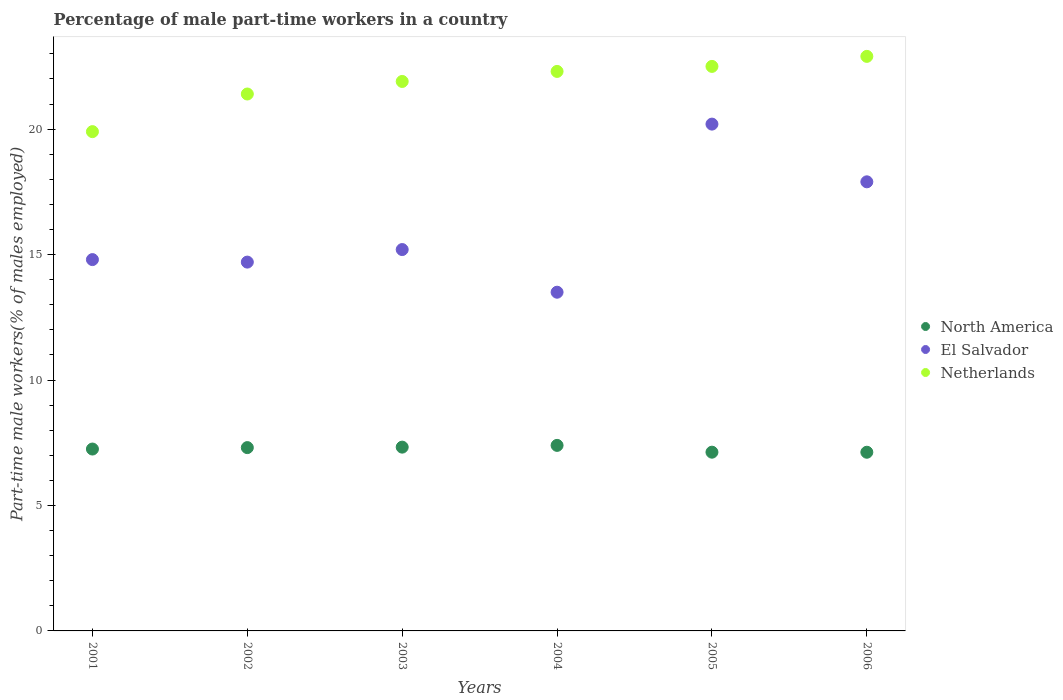How many different coloured dotlines are there?
Keep it short and to the point. 3. What is the percentage of male part-time workers in North America in 2006?
Make the answer very short. 7.12. Across all years, what is the maximum percentage of male part-time workers in El Salvador?
Make the answer very short. 20.2. Across all years, what is the minimum percentage of male part-time workers in El Salvador?
Provide a short and direct response. 13.5. In which year was the percentage of male part-time workers in North America minimum?
Keep it short and to the point. 2006. What is the total percentage of male part-time workers in Netherlands in the graph?
Ensure brevity in your answer.  130.9. What is the difference between the percentage of male part-time workers in Netherlands in 2003 and that in 2006?
Make the answer very short. -1. What is the difference between the percentage of male part-time workers in Netherlands in 2004 and the percentage of male part-time workers in El Salvador in 2002?
Offer a terse response. 7.6. What is the average percentage of male part-time workers in El Salvador per year?
Ensure brevity in your answer.  16.05. In the year 2004, what is the difference between the percentage of male part-time workers in Netherlands and percentage of male part-time workers in North America?
Your response must be concise. 14.91. What is the ratio of the percentage of male part-time workers in El Salvador in 2002 to that in 2005?
Keep it short and to the point. 0.73. Is the difference between the percentage of male part-time workers in Netherlands in 2002 and 2006 greater than the difference between the percentage of male part-time workers in North America in 2002 and 2006?
Keep it short and to the point. No. What is the difference between the highest and the second highest percentage of male part-time workers in El Salvador?
Keep it short and to the point. 2.3. What is the difference between the highest and the lowest percentage of male part-time workers in North America?
Keep it short and to the point. 0.27. Is the sum of the percentage of male part-time workers in El Salvador in 2001 and 2006 greater than the maximum percentage of male part-time workers in Netherlands across all years?
Make the answer very short. Yes. Is the percentage of male part-time workers in El Salvador strictly greater than the percentage of male part-time workers in North America over the years?
Provide a short and direct response. Yes. Is the percentage of male part-time workers in El Salvador strictly less than the percentage of male part-time workers in Netherlands over the years?
Offer a very short reply. Yes. How many dotlines are there?
Keep it short and to the point. 3. How many years are there in the graph?
Keep it short and to the point. 6. Are the values on the major ticks of Y-axis written in scientific E-notation?
Offer a very short reply. No. Does the graph contain grids?
Your answer should be very brief. No. How are the legend labels stacked?
Provide a succinct answer. Vertical. What is the title of the graph?
Make the answer very short. Percentage of male part-time workers in a country. What is the label or title of the X-axis?
Provide a succinct answer. Years. What is the label or title of the Y-axis?
Offer a terse response. Part-time male workers(% of males employed). What is the Part-time male workers(% of males employed) of North America in 2001?
Make the answer very short. 7.25. What is the Part-time male workers(% of males employed) of El Salvador in 2001?
Offer a very short reply. 14.8. What is the Part-time male workers(% of males employed) in Netherlands in 2001?
Offer a terse response. 19.9. What is the Part-time male workers(% of males employed) in North America in 2002?
Offer a very short reply. 7.31. What is the Part-time male workers(% of males employed) of El Salvador in 2002?
Keep it short and to the point. 14.7. What is the Part-time male workers(% of males employed) in Netherlands in 2002?
Provide a succinct answer. 21.4. What is the Part-time male workers(% of males employed) of North America in 2003?
Provide a succinct answer. 7.33. What is the Part-time male workers(% of males employed) of El Salvador in 2003?
Give a very brief answer. 15.2. What is the Part-time male workers(% of males employed) in Netherlands in 2003?
Offer a terse response. 21.9. What is the Part-time male workers(% of males employed) in North America in 2004?
Keep it short and to the point. 7.39. What is the Part-time male workers(% of males employed) in Netherlands in 2004?
Your answer should be very brief. 22.3. What is the Part-time male workers(% of males employed) in North America in 2005?
Provide a succinct answer. 7.12. What is the Part-time male workers(% of males employed) of El Salvador in 2005?
Offer a very short reply. 20.2. What is the Part-time male workers(% of males employed) in North America in 2006?
Provide a succinct answer. 7.12. What is the Part-time male workers(% of males employed) in El Salvador in 2006?
Ensure brevity in your answer.  17.9. What is the Part-time male workers(% of males employed) of Netherlands in 2006?
Your answer should be very brief. 22.9. Across all years, what is the maximum Part-time male workers(% of males employed) in North America?
Provide a succinct answer. 7.39. Across all years, what is the maximum Part-time male workers(% of males employed) of El Salvador?
Your answer should be very brief. 20.2. Across all years, what is the maximum Part-time male workers(% of males employed) of Netherlands?
Give a very brief answer. 22.9. Across all years, what is the minimum Part-time male workers(% of males employed) of North America?
Your response must be concise. 7.12. Across all years, what is the minimum Part-time male workers(% of males employed) of Netherlands?
Provide a short and direct response. 19.9. What is the total Part-time male workers(% of males employed) in North America in the graph?
Your answer should be very brief. 43.52. What is the total Part-time male workers(% of males employed) of El Salvador in the graph?
Your answer should be compact. 96.3. What is the total Part-time male workers(% of males employed) of Netherlands in the graph?
Provide a short and direct response. 130.9. What is the difference between the Part-time male workers(% of males employed) of North America in 2001 and that in 2002?
Offer a terse response. -0.06. What is the difference between the Part-time male workers(% of males employed) in North America in 2001 and that in 2003?
Ensure brevity in your answer.  -0.08. What is the difference between the Part-time male workers(% of males employed) in El Salvador in 2001 and that in 2003?
Make the answer very short. -0.4. What is the difference between the Part-time male workers(% of males employed) in North America in 2001 and that in 2004?
Keep it short and to the point. -0.15. What is the difference between the Part-time male workers(% of males employed) of El Salvador in 2001 and that in 2004?
Make the answer very short. 1.3. What is the difference between the Part-time male workers(% of males employed) in Netherlands in 2001 and that in 2004?
Your answer should be compact. -2.4. What is the difference between the Part-time male workers(% of males employed) of North America in 2001 and that in 2005?
Your response must be concise. 0.13. What is the difference between the Part-time male workers(% of males employed) of North America in 2001 and that in 2006?
Your response must be concise. 0.13. What is the difference between the Part-time male workers(% of males employed) of El Salvador in 2001 and that in 2006?
Your answer should be compact. -3.1. What is the difference between the Part-time male workers(% of males employed) of Netherlands in 2001 and that in 2006?
Your answer should be compact. -3. What is the difference between the Part-time male workers(% of males employed) of North America in 2002 and that in 2003?
Make the answer very short. -0.02. What is the difference between the Part-time male workers(% of males employed) of El Salvador in 2002 and that in 2003?
Make the answer very short. -0.5. What is the difference between the Part-time male workers(% of males employed) of North America in 2002 and that in 2004?
Give a very brief answer. -0.09. What is the difference between the Part-time male workers(% of males employed) of El Salvador in 2002 and that in 2004?
Your answer should be very brief. 1.2. What is the difference between the Part-time male workers(% of males employed) in Netherlands in 2002 and that in 2004?
Make the answer very short. -0.9. What is the difference between the Part-time male workers(% of males employed) in North America in 2002 and that in 2005?
Your response must be concise. 0.18. What is the difference between the Part-time male workers(% of males employed) in El Salvador in 2002 and that in 2005?
Provide a succinct answer. -5.5. What is the difference between the Part-time male workers(% of males employed) of Netherlands in 2002 and that in 2005?
Provide a short and direct response. -1.1. What is the difference between the Part-time male workers(% of males employed) in North America in 2002 and that in 2006?
Give a very brief answer. 0.18. What is the difference between the Part-time male workers(% of males employed) in El Salvador in 2002 and that in 2006?
Make the answer very short. -3.2. What is the difference between the Part-time male workers(% of males employed) in North America in 2003 and that in 2004?
Give a very brief answer. -0.07. What is the difference between the Part-time male workers(% of males employed) of Netherlands in 2003 and that in 2004?
Keep it short and to the point. -0.4. What is the difference between the Part-time male workers(% of males employed) in North America in 2003 and that in 2005?
Provide a succinct answer. 0.2. What is the difference between the Part-time male workers(% of males employed) of El Salvador in 2003 and that in 2005?
Your response must be concise. -5. What is the difference between the Part-time male workers(% of males employed) of North America in 2003 and that in 2006?
Provide a short and direct response. 0.2. What is the difference between the Part-time male workers(% of males employed) of Netherlands in 2003 and that in 2006?
Ensure brevity in your answer.  -1. What is the difference between the Part-time male workers(% of males employed) of North America in 2004 and that in 2005?
Ensure brevity in your answer.  0.27. What is the difference between the Part-time male workers(% of males employed) in Netherlands in 2004 and that in 2005?
Offer a very short reply. -0.2. What is the difference between the Part-time male workers(% of males employed) of North America in 2004 and that in 2006?
Offer a terse response. 0.27. What is the difference between the Part-time male workers(% of males employed) in El Salvador in 2004 and that in 2006?
Keep it short and to the point. -4.4. What is the difference between the Part-time male workers(% of males employed) in North America in 2005 and that in 2006?
Give a very brief answer. 0. What is the difference between the Part-time male workers(% of males employed) of North America in 2001 and the Part-time male workers(% of males employed) of El Salvador in 2002?
Offer a terse response. -7.45. What is the difference between the Part-time male workers(% of males employed) of North America in 2001 and the Part-time male workers(% of males employed) of Netherlands in 2002?
Provide a short and direct response. -14.15. What is the difference between the Part-time male workers(% of males employed) in North America in 2001 and the Part-time male workers(% of males employed) in El Salvador in 2003?
Offer a very short reply. -7.95. What is the difference between the Part-time male workers(% of males employed) in North America in 2001 and the Part-time male workers(% of males employed) in Netherlands in 2003?
Make the answer very short. -14.65. What is the difference between the Part-time male workers(% of males employed) in El Salvador in 2001 and the Part-time male workers(% of males employed) in Netherlands in 2003?
Offer a very short reply. -7.1. What is the difference between the Part-time male workers(% of males employed) of North America in 2001 and the Part-time male workers(% of males employed) of El Salvador in 2004?
Ensure brevity in your answer.  -6.25. What is the difference between the Part-time male workers(% of males employed) in North America in 2001 and the Part-time male workers(% of males employed) in Netherlands in 2004?
Offer a very short reply. -15.05. What is the difference between the Part-time male workers(% of males employed) in El Salvador in 2001 and the Part-time male workers(% of males employed) in Netherlands in 2004?
Your answer should be compact. -7.5. What is the difference between the Part-time male workers(% of males employed) in North America in 2001 and the Part-time male workers(% of males employed) in El Salvador in 2005?
Your answer should be very brief. -12.95. What is the difference between the Part-time male workers(% of males employed) of North America in 2001 and the Part-time male workers(% of males employed) of Netherlands in 2005?
Keep it short and to the point. -15.25. What is the difference between the Part-time male workers(% of males employed) of El Salvador in 2001 and the Part-time male workers(% of males employed) of Netherlands in 2005?
Make the answer very short. -7.7. What is the difference between the Part-time male workers(% of males employed) of North America in 2001 and the Part-time male workers(% of males employed) of El Salvador in 2006?
Keep it short and to the point. -10.65. What is the difference between the Part-time male workers(% of males employed) of North America in 2001 and the Part-time male workers(% of males employed) of Netherlands in 2006?
Provide a succinct answer. -15.65. What is the difference between the Part-time male workers(% of males employed) in El Salvador in 2001 and the Part-time male workers(% of males employed) in Netherlands in 2006?
Offer a very short reply. -8.1. What is the difference between the Part-time male workers(% of males employed) in North America in 2002 and the Part-time male workers(% of males employed) in El Salvador in 2003?
Offer a very short reply. -7.89. What is the difference between the Part-time male workers(% of males employed) of North America in 2002 and the Part-time male workers(% of males employed) of Netherlands in 2003?
Provide a short and direct response. -14.59. What is the difference between the Part-time male workers(% of males employed) in North America in 2002 and the Part-time male workers(% of males employed) in El Salvador in 2004?
Offer a very short reply. -6.19. What is the difference between the Part-time male workers(% of males employed) of North America in 2002 and the Part-time male workers(% of males employed) of Netherlands in 2004?
Ensure brevity in your answer.  -14.99. What is the difference between the Part-time male workers(% of males employed) of North America in 2002 and the Part-time male workers(% of males employed) of El Salvador in 2005?
Provide a succinct answer. -12.89. What is the difference between the Part-time male workers(% of males employed) in North America in 2002 and the Part-time male workers(% of males employed) in Netherlands in 2005?
Offer a very short reply. -15.19. What is the difference between the Part-time male workers(% of males employed) in El Salvador in 2002 and the Part-time male workers(% of males employed) in Netherlands in 2005?
Provide a short and direct response. -7.8. What is the difference between the Part-time male workers(% of males employed) in North America in 2002 and the Part-time male workers(% of males employed) in El Salvador in 2006?
Ensure brevity in your answer.  -10.59. What is the difference between the Part-time male workers(% of males employed) in North America in 2002 and the Part-time male workers(% of males employed) in Netherlands in 2006?
Make the answer very short. -15.59. What is the difference between the Part-time male workers(% of males employed) in North America in 2003 and the Part-time male workers(% of males employed) in El Salvador in 2004?
Give a very brief answer. -6.17. What is the difference between the Part-time male workers(% of males employed) in North America in 2003 and the Part-time male workers(% of males employed) in Netherlands in 2004?
Keep it short and to the point. -14.97. What is the difference between the Part-time male workers(% of males employed) in North America in 2003 and the Part-time male workers(% of males employed) in El Salvador in 2005?
Offer a terse response. -12.87. What is the difference between the Part-time male workers(% of males employed) of North America in 2003 and the Part-time male workers(% of males employed) of Netherlands in 2005?
Your response must be concise. -15.17. What is the difference between the Part-time male workers(% of males employed) in North America in 2003 and the Part-time male workers(% of males employed) in El Salvador in 2006?
Offer a very short reply. -10.57. What is the difference between the Part-time male workers(% of males employed) of North America in 2003 and the Part-time male workers(% of males employed) of Netherlands in 2006?
Keep it short and to the point. -15.57. What is the difference between the Part-time male workers(% of males employed) of North America in 2004 and the Part-time male workers(% of males employed) of El Salvador in 2005?
Provide a short and direct response. -12.81. What is the difference between the Part-time male workers(% of males employed) in North America in 2004 and the Part-time male workers(% of males employed) in Netherlands in 2005?
Ensure brevity in your answer.  -15.11. What is the difference between the Part-time male workers(% of males employed) in El Salvador in 2004 and the Part-time male workers(% of males employed) in Netherlands in 2005?
Make the answer very short. -9. What is the difference between the Part-time male workers(% of males employed) of North America in 2004 and the Part-time male workers(% of males employed) of El Salvador in 2006?
Give a very brief answer. -10.51. What is the difference between the Part-time male workers(% of males employed) in North America in 2004 and the Part-time male workers(% of males employed) in Netherlands in 2006?
Provide a short and direct response. -15.51. What is the difference between the Part-time male workers(% of males employed) in El Salvador in 2004 and the Part-time male workers(% of males employed) in Netherlands in 2006?
Your answer should be compact. -9.4. What is the difference between the Part-time male workers(% of males employed) of North America in 2005 and the Part-time male workers(% of males employed) of El Salvador in 2006?
Provide a succinct answer. -10.78. What is the difference between the Part-time male workers(% of males employed) of North America in 2005 and the Part-time male workers(% of males employed) of Netherlands in 2006?
Your response must be concise. -15.78. What is the average Part-time male workers(% of males employed) in North America per year?
Your answer should be compact. 7.25. What is the average Part-time male workers(% of males employed) of El Salvador per year?
Ensure brevity in your answer.  16.05. What is the average Part-time male workers(% of males employed) of Netherlands per year?
Offer a very short reply. 21.82. In the year 2001, what is the difference between the Part-time male workers(% of males employed) in North America and Part-time male workers(% of males employed) in El Salvador?
Provide a succinct answer. -7.55. In the year 2001, what is the difference between the Part-time male workers(% of males employed) of North America and Part-time male workers(% of males employed) of Netherlands?
Your response must be concise. -12.65. In the year 2002, what is the difference between the Part-time male workers(% of males employed) of North America and Part-time male workers(% of males employed) of El Salvador?
Make the answer very short. -7.39. In the year 2002, what is the difference between the Part-time male workers(% of males employed) in North America and Part-time male workers(% of males employed) in Netherlands?
Keep it short and to the point. -14.09. In the year 2003, what is the difference between the Part-time male workers(% of males employed) of North America and Part-time male workers(% of males employed) of El Salvador?
Offer a terse response. -7.87. In the year 2003, what is the difference between the Part-time male workers(% of males employed) in North America and Part-time male workers(% of males employed) in Netherlands?
Provide a short and direct response. -14.57. In the year 2004, what is the difference between the Part-time male workers(% of males employed) of North America and Part-time male workers(% of males employed) of El Salvador?
Your answer should be very brief. -6.11. In the year 2004, what is the difference between the Part-time male workers(% of males employed) in North America and Part-time male workers(% of males employed) in Netherlands?
Provide a succinct answer. -14.91. In the year 2004, what is the difference between the Part-time male workers(% of males employed) in El Salvador and Part-time male workers(% of males employed) in Netherlands?
Offer a terse response. -8.8. In the year 2005, what is the difference between the Part-time male workers(% of males employed) of North America and Part-time male workers(% of males employed) of El Salvador?
Your answer should be very brief. -13.08. In the year 2005, what is the difference between the Part-time male workers(% of males employed) in North America and Part-time male workers(% of males employed) in Netherlands?
Keep it short and to the point. -15.38. In the year 2006, what is the difference between the Part-time male workers(% of males employed) of North America and Part-time male workers(% of males employed) of El Salvador?
Provide a succinct answer. -10.78. In the year 2006, what is the difference between the Part-time male workers(% of males employed) of North America and Part-time male workers(% of males employed) of Netherlands?
Give a very brief answer. -15.78. What is the ratio of the Part-time male workers(% of males employed) in El Salvador in 2001 to that in 2002?
Offer a terse response. 1.01. What is the ratio of the Part-time male workers(% of males employed) in Netherlands in 2001 to that in 2002?
Your response must be concise. 0.93. What is the ratio of the Part-time male workers(% of males employed) of El Salvador in 2001 to that in 2003?
Your answer should be very brief. 0.97. What is the ratio of the Part-time male workers(% of males employed) in Netherlands in 2001 to that in 2003?
Keep it short and to the point. 0.91. What is the ratio of the Part-time male workers(% of males employed) of North America in 2001 to that in 2004?
Provide a succinct answer. 0.98. What is the ratio of the Part-time male workers(% of males employed) of El Salvador in 2001 to that in 2004?
Your answer should be compact. 1.1. What is the ratio of the Part-time male workers(% of males employed) of Netherlands in 2001 to that in 2004?
Give a very brief answer. 0.89. What is the ratio of the Part-time male workers(% of males employed) of North America in 2001 to that in 2005?
Ensure brevity in your answer.  1.02. What is the ratio of the Part-time male workers(% of males employed) of El Salvador in 2001 to that in 2005?
Offer a very short reply. 0.73. What is the ratio of the Part-time male workers(% of males employed) of Netherlands in 2001 to that in 2005?
Keep it short and to the point. 0.88. What is the ratio of the Part-time male workers(% of males employed) of El Salvador in 2001 to that in 2006?
Ensure brevity in your answer.  0.83. What is the ratio of the Part-time male workers(% of males employed) in Netherlands in 2001 to that in 2006?
Offer a very short reply. 0.87. What is the ratio of the Part-time male workers(% of males employed) in El Salvador in 2002 to that in 2003?
Your answer should be compact. 0.97. What is the ratio of the Part-time male workers(% of males employed) in Netherlands in 2002 to that in 2003?
Provide a short and direct response. 0.98. What is the ratio of the Part-time male workers(% of males employed) in North America in 2002 to that in 2004?
Make the answer very short. 0.99. What is the ratio of the Part-time male workers(% of males employed) of El Salvador in 2002 to that in 2004?
Offer a very short reply. 1.09. What is the ratio of the Part-time male workers(% of males employed) of Netherlands in 2002 to that in 2004?
Offer a terse response. 0.96. What is the ratio of the Part-time male workers(% of males employed) in North America in 2002 to that in 2005?
Provide a succinct answer. 1.03. What is the ratio of the Part-time male workers(% of males employed) in El Salvador in 2002 to that in 2005?
Provide a short and direct response. 0.73. What is the ratio of the Part-time male workers(% of males employed) in Netherlands in 2002 to that in 2005?
Offer a terse response. 0.95. What is the ratio of the Part-time male workers(% of males employed) in North America in 2002 to that in 2006?
Provide a short and direct response. 1.03. What is the ratio of the Part-time male workers(% of males employed) of El Salvador in 2002 to that in 2006?
Your response must be concise. 0.82. What is the ratio of the Part-time male workers(% of males employed) in Netherlands in 2002 to that in 2006?
Offer a very short reply. 0.93. What is the ratio of the Part-time male workers(% of males employed) of North America in 2003 to that in 2004?
Provide a succinct answer. 0.99. What is the ratio of the Part-time male workers(% of males employed) of El Salvador in 2003 to that in 2004?
Ensure brevity in your answer.  1.13. What is the ratio of the Part-time male workers(% of males employed) of Netherlands in 2003 to that in 2004?
Your answer should be very brief. 0.98. What is the ratio of the Part-time male workers(% of males employed) of North America in 2003 to that in 2005?
Give a very brief answer. 1.03. What is the ratio of the Part-time male workers(% of males employed) in El Salvador in 2003 to that in 2005?
Provide a short and direct response. 0.75. What is the ratio of the Part-time male workers(% of males employed) in Netherlands in 2003 to that in 2005?
Your answer should be very brief. 0.97. What is the ratio of the Part-time male workers(% of males employed) of North America in 2003 to that in 2006?
Provide a short and direct response. 1.03. What is the ratio of the Part-time male workers(% of males employed) of El Salvador in 2003 to that in 2006?
Your response must be concise. 0.85. What is the ratio of the Part-time male workers(% of males employed) of Netherlands in 2003 to that in 2006?
Offer a very short reply. 0.96. What is the ratio of the Part-time male workers(% of males employed) in North America in 2004 to that in 2005?
Ensure brevity in your answer.  1.04. What is the ratio of the Part-time male workers(% of males employed) in El Salvador in 2004 to that in 2005?
Offer a terse response. 0.67. What is the ratio of the Part-time male workers(% of males employed) of North America in 2004 to that in 2006?
Your response must be concise. 1.04. What is the ratio of the Part-time male workers(% of males employed) of El Salvador in 2004 to that in 2006?
Offer a very short reply. 0.75. What is the ratio of the Part-time male workers(% of males employed) of Netherlands in 2004 to that in 2006?
Your answer should be compact. 0.97. What is the ratio of the Part-time male workers(% of males employed) of El Salvador in 2005 to that in 2006?
Ensure brevity in your answer.  1.13. What is the ratio of the Part-time male workers(% of males employed) of Netherlands in 2005 to that in 2006?
Give a very brief answer. 0.98. What is the difference between the highest and the second highest Part-time male workers(% of males employed) of North America?
Your answer should be very brief. 0.07. What is the difference between the highest and the second highest Part-time male workers(% of males employed) of Netherlands?
Offer a terse response. 0.4. What is the difference between the highest and the lowest Part-time male workers(% of males employed) of North America?
Your response must be concise. 0.27. What is the difference between the highest and the lowest Part-time male workers(% of males employed) in Netherlands?
Your answer should be very brief. 3. 